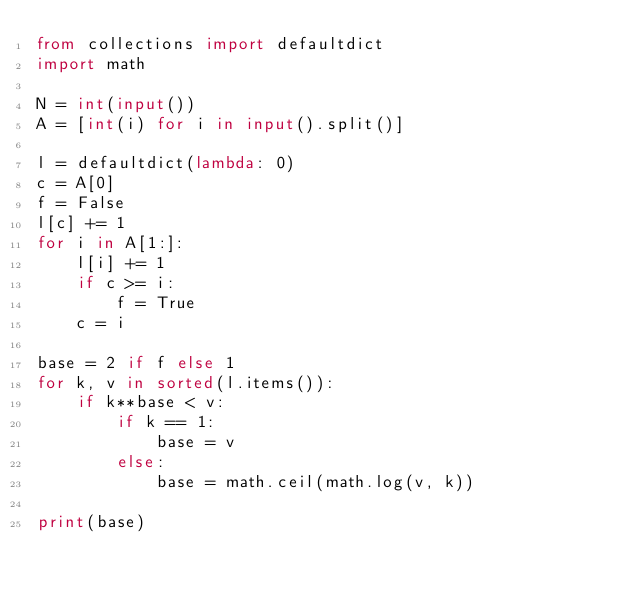Convert code to text. <code><loc_0><loc_0><loc_500><loc_500><_Python_>from collections import defaultdict
import math
 
N = int(input())
A = [int(i) for i in input().split()]
 
l = defaultdict(lambda: 0)
c = A[0]
f = False
l[c] += 1
for i in A[1:]:
    l[i] += 1
    if c >= i:
        f = True
    c = i
 
base = 2 if f else 1
for k, v in sorted(l.items()):
    if k**base < v:
        if k == 1:
            base = v
        else:
            base = math.ceil(math.log(v, k))
 
print(base)</code> 